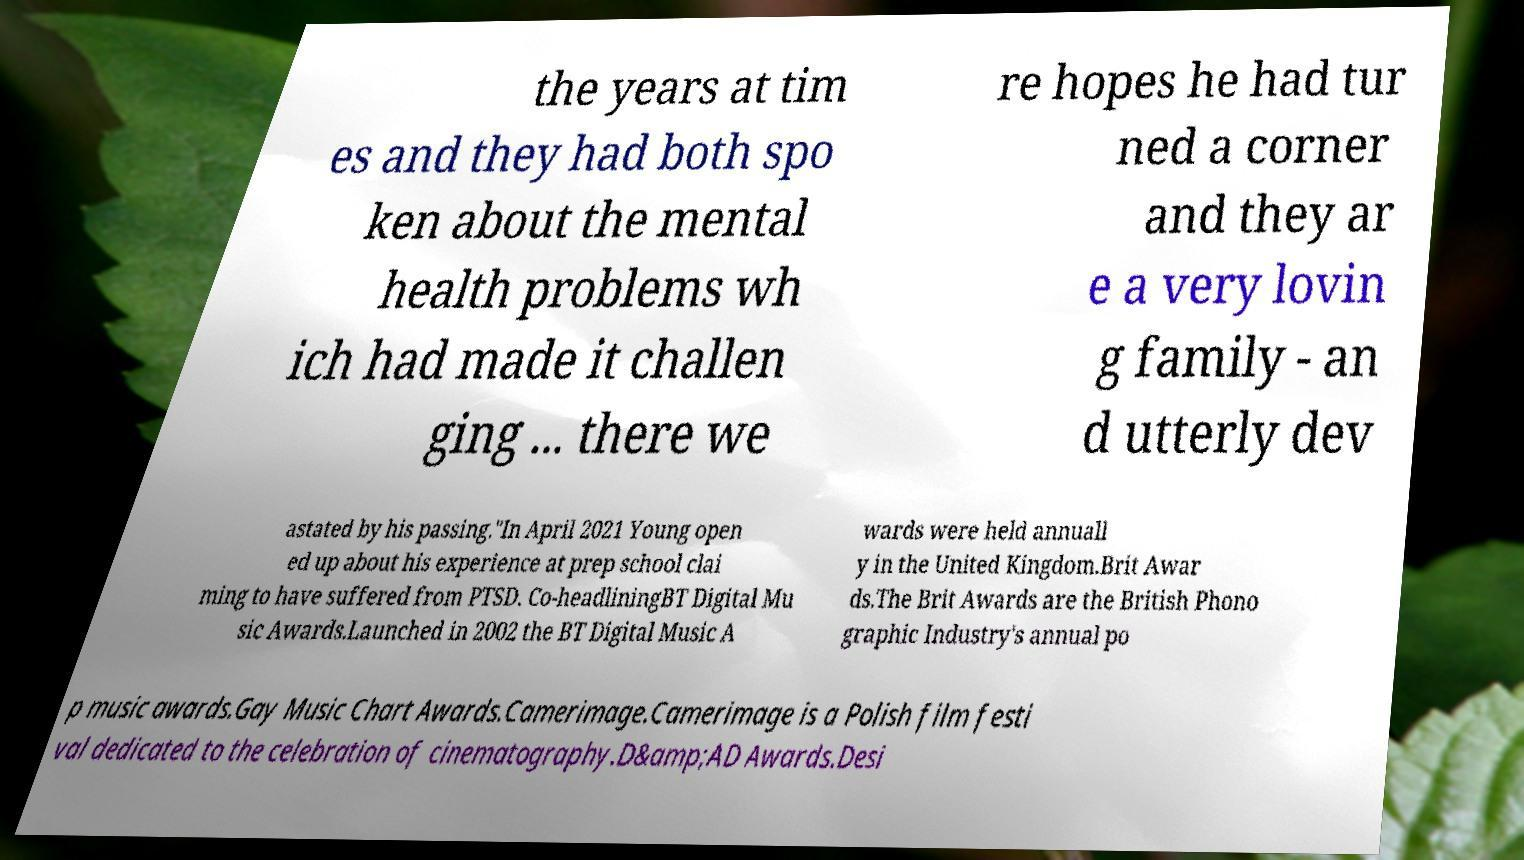Can you accurately transcribe the text from the provided image for me? the years at tim es and they had both spo ken about the mental health problems wh ich had made it challen ging ... there we re hopes he had tur ned a corner and they ar e a very lovin g family - an d utterly dev astated by his passing."In April 2021 Young open ed up about his experience at prep school clai ming to have suffered from PTSD. Co-headliningBT Digital Mu sic Awards.Launched in 2002 the BT Digital Music A wards were held annuall y in the United Kingdom.Brit Awar ds.The Brit Awards are the British Phono graphic Industry's annual po p music awards.Gay Music Chart Awards.Camerimage.Camerimage is a Polish film festi val dedicated to the celebration of cinematography.D&amp;AD Awards.Desi 